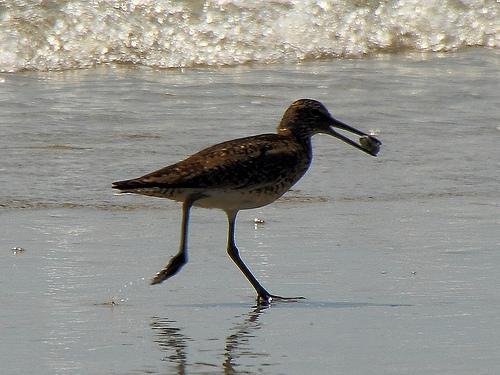How many birds are there?
Give a very brief answer. 1. 